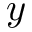<formula> <loc_0><loc_0><loc_500><loc_500>y</formula> 